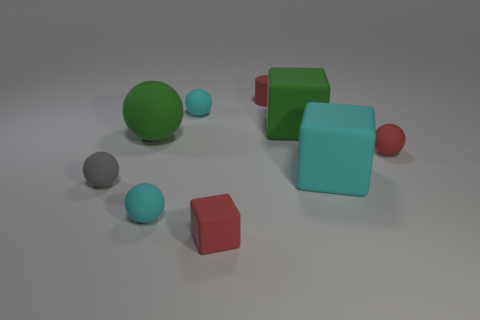Is there a big thing on the right side of the tiny red object that is in front of the tiny red matte object right of the large cyan cube?
Offer a terse response. Yes. What number of gray rubber spheres have the same size as the gray object?
Offer a terse response. 0. There is a tiny cyan matte thing to the left of the small cyan object that is to the right of the cyan sphere in front of the red ball; what shape is it?
Your answer should be very brief. Sphere. Is the shape of the red rubber thing to the right of the tiny red rubber cylinder the same as the big matte object on the left side of the cylinder?
Ensure brevity in your answer.  Yes. How many other objects are there of the same material as the big green block?
Offer a terse response. 8. There is a gray thing that is made of the same material as the tiny red block; what is its shape?
Give a very brief answer. Sphere. Do the gray rubber object and the red matte cube have the same size?
Provide a succinct answer. Yes. How big is the object that is on the left side of the green rubber object that is left of the matte cylinder?
Give a very brief answer. Small. There is a rubber thing that is the same color as the big ball; what is its shape?
Your answer should be very brief. Cube. How many spheres are small gray matte objects or big cyan things?
Your answer should be compact. 1. 